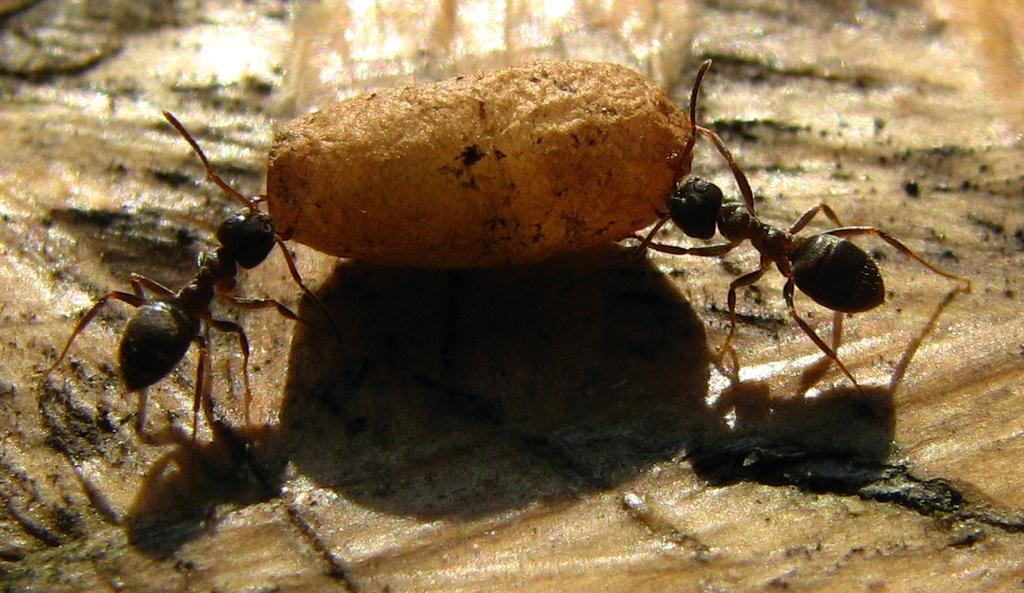What creatures can be seen in the foreground of the image? There are two ants in the foreground of the image. What is located on the ground in the foreground of the image? There is an object on the ground in the foreground of the image. What is the weather condition in the image? The image was taken during a rainy day. How do the horses compare in size to the ants in the image? There are no horses present in the image, so it is not possible to make a comparison. 